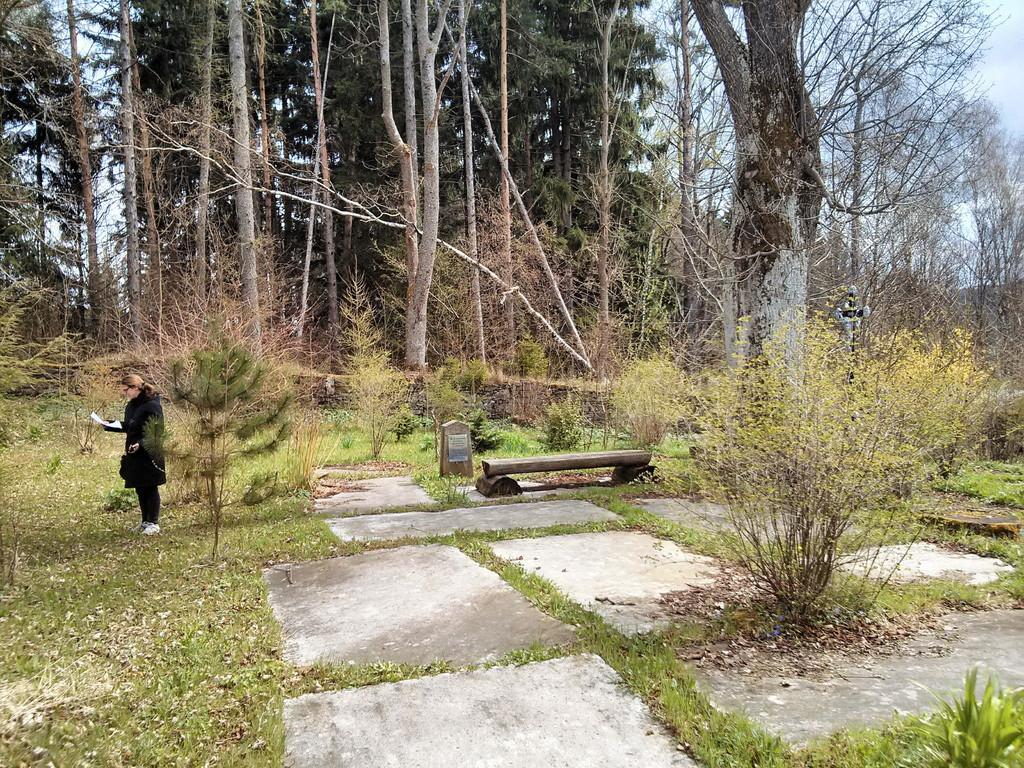Can you describe this image briefly? In this picture there is a girl on the left side of the image, by holding a paper in her hand and there is a log in the center of the image, there is greenery around the image. 